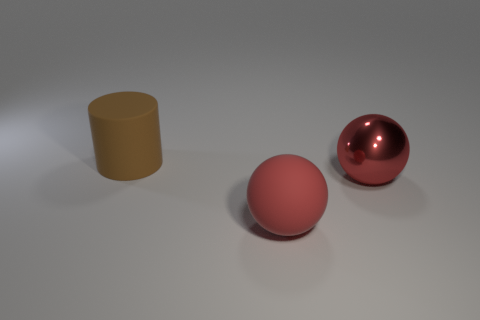There is a red sphere that is made of the same material as the big cylinder; what is its size?
Your response must be concise. Large. Are there any other things of the same color as the large cylinder?
Ensure brevity in your answer.  No. Do the cylinder and the sphere that is behind the big red matte sphere have the same material?
Keep it short and to the point. No. There is another big thing that is the same shape as the red matte thing; what is it made of?
Offer a very short reply. Metal. Are the object that is behind the metal thing and the red ball that is behind the big red rubber ball made of the same material?
Provide a short and direct response. No. There is a large sphere in front of the large red ball behind the big sphere to the left of the metallic thing; what color is it?
Ensure brevity in your answer.  Red. How many other things are the same shape as the big red shiny thing?
Offer a terse response. 1. Is the big matte sphere the same color as the matte cylinder?
Your response must be concise. No. How many things are either big brown matte cylinders or objects on the right side of the large brown rubber cylinder?
Ensure brevity in your answer.  3. Is there a red object that has the same size as the cylinder?
Ensure brevity in your answer.  Yes. 